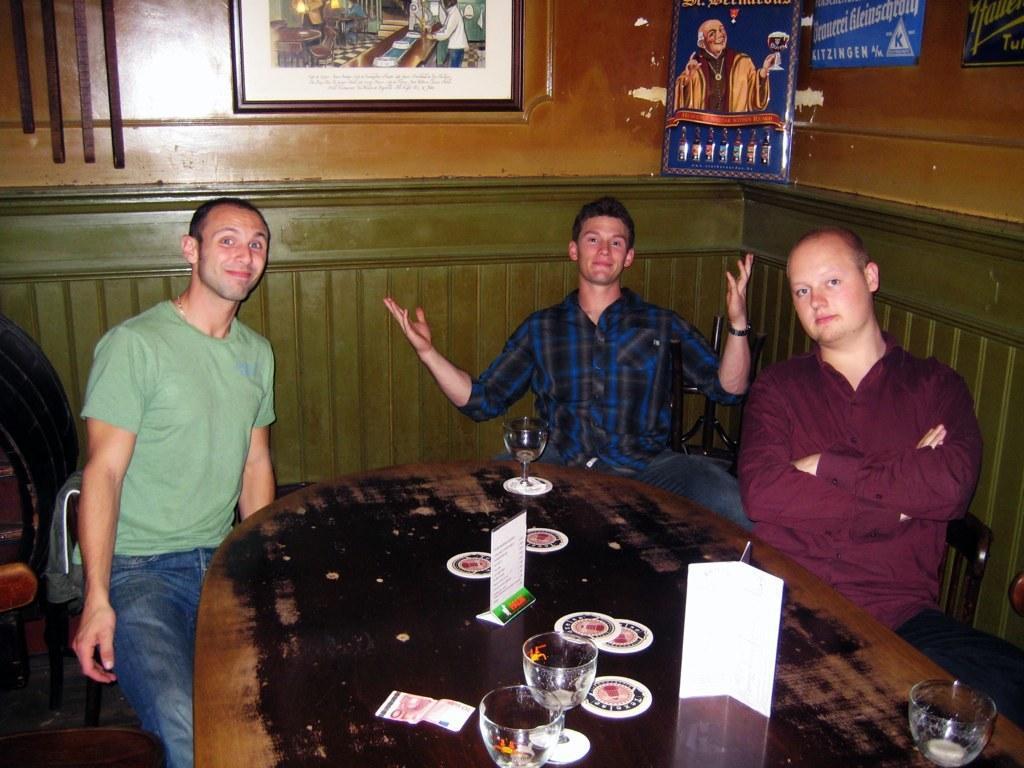Please provide a concise description of this image. In this image, there are three men sitting on the chairs. I can see a table with the wine glasses, cards and few other things on it. In the background, I can see the photo frames, which are attached to the wooden wall. On the left side of the image, I can see an object. 